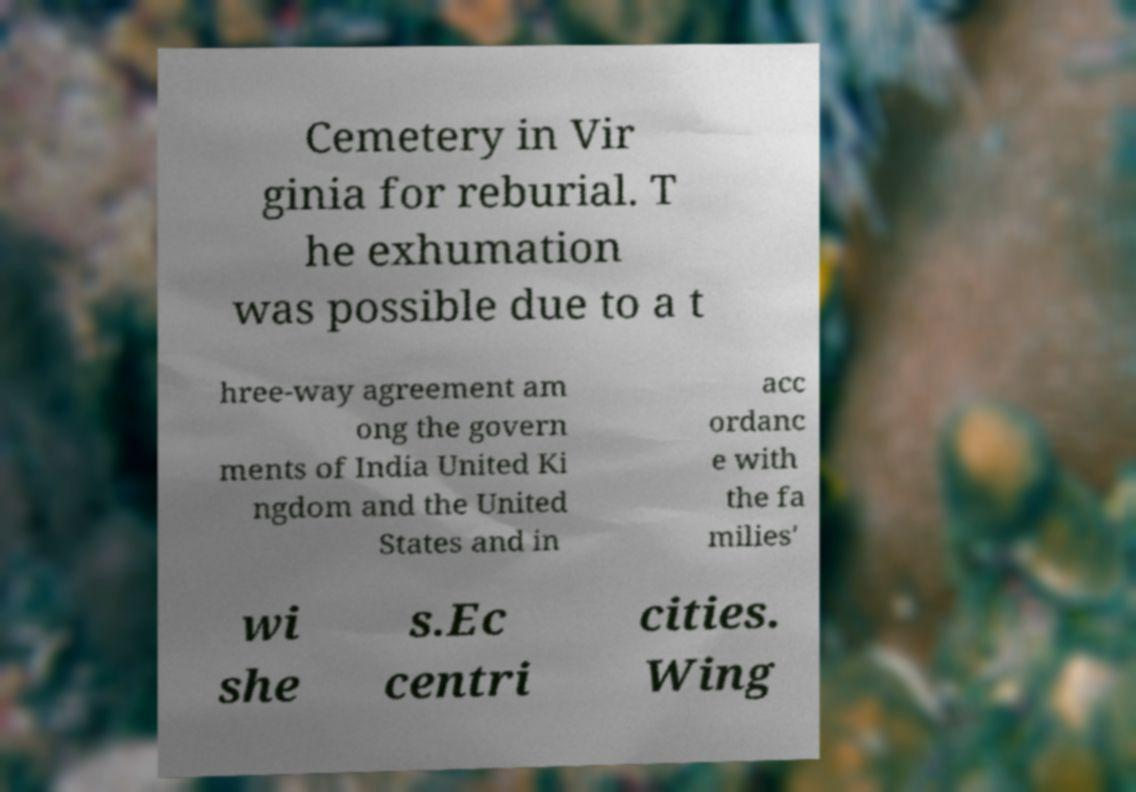Could you extract and type out the text from this image? Cemetery in Vir ginia for reburial. T he exhumation was possible due to a t hree-way agreement am ong the govern ments of India United Ki ngdom and the United States and in acc ordanc e with the fa milies' wi she s.Ec centri cities. Wing 